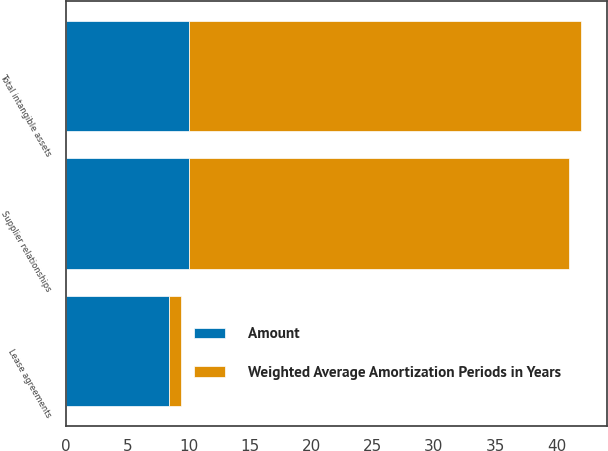Convert chart to OTSL. <chart><loc_0><loc_0><loc_500><loc_500><stacked_bar_chart><ecel><fcel>Supplier relationships<fcel>Lease agreements<fcel>Total intangible assets<nl><fcel>Weighted Average Amortization Periods in Years<fcel>31<fcel>1<fcel>32<nl><fcel>Amount<fcel>10<fcel>8.4<fcel>10<nl></chart> 